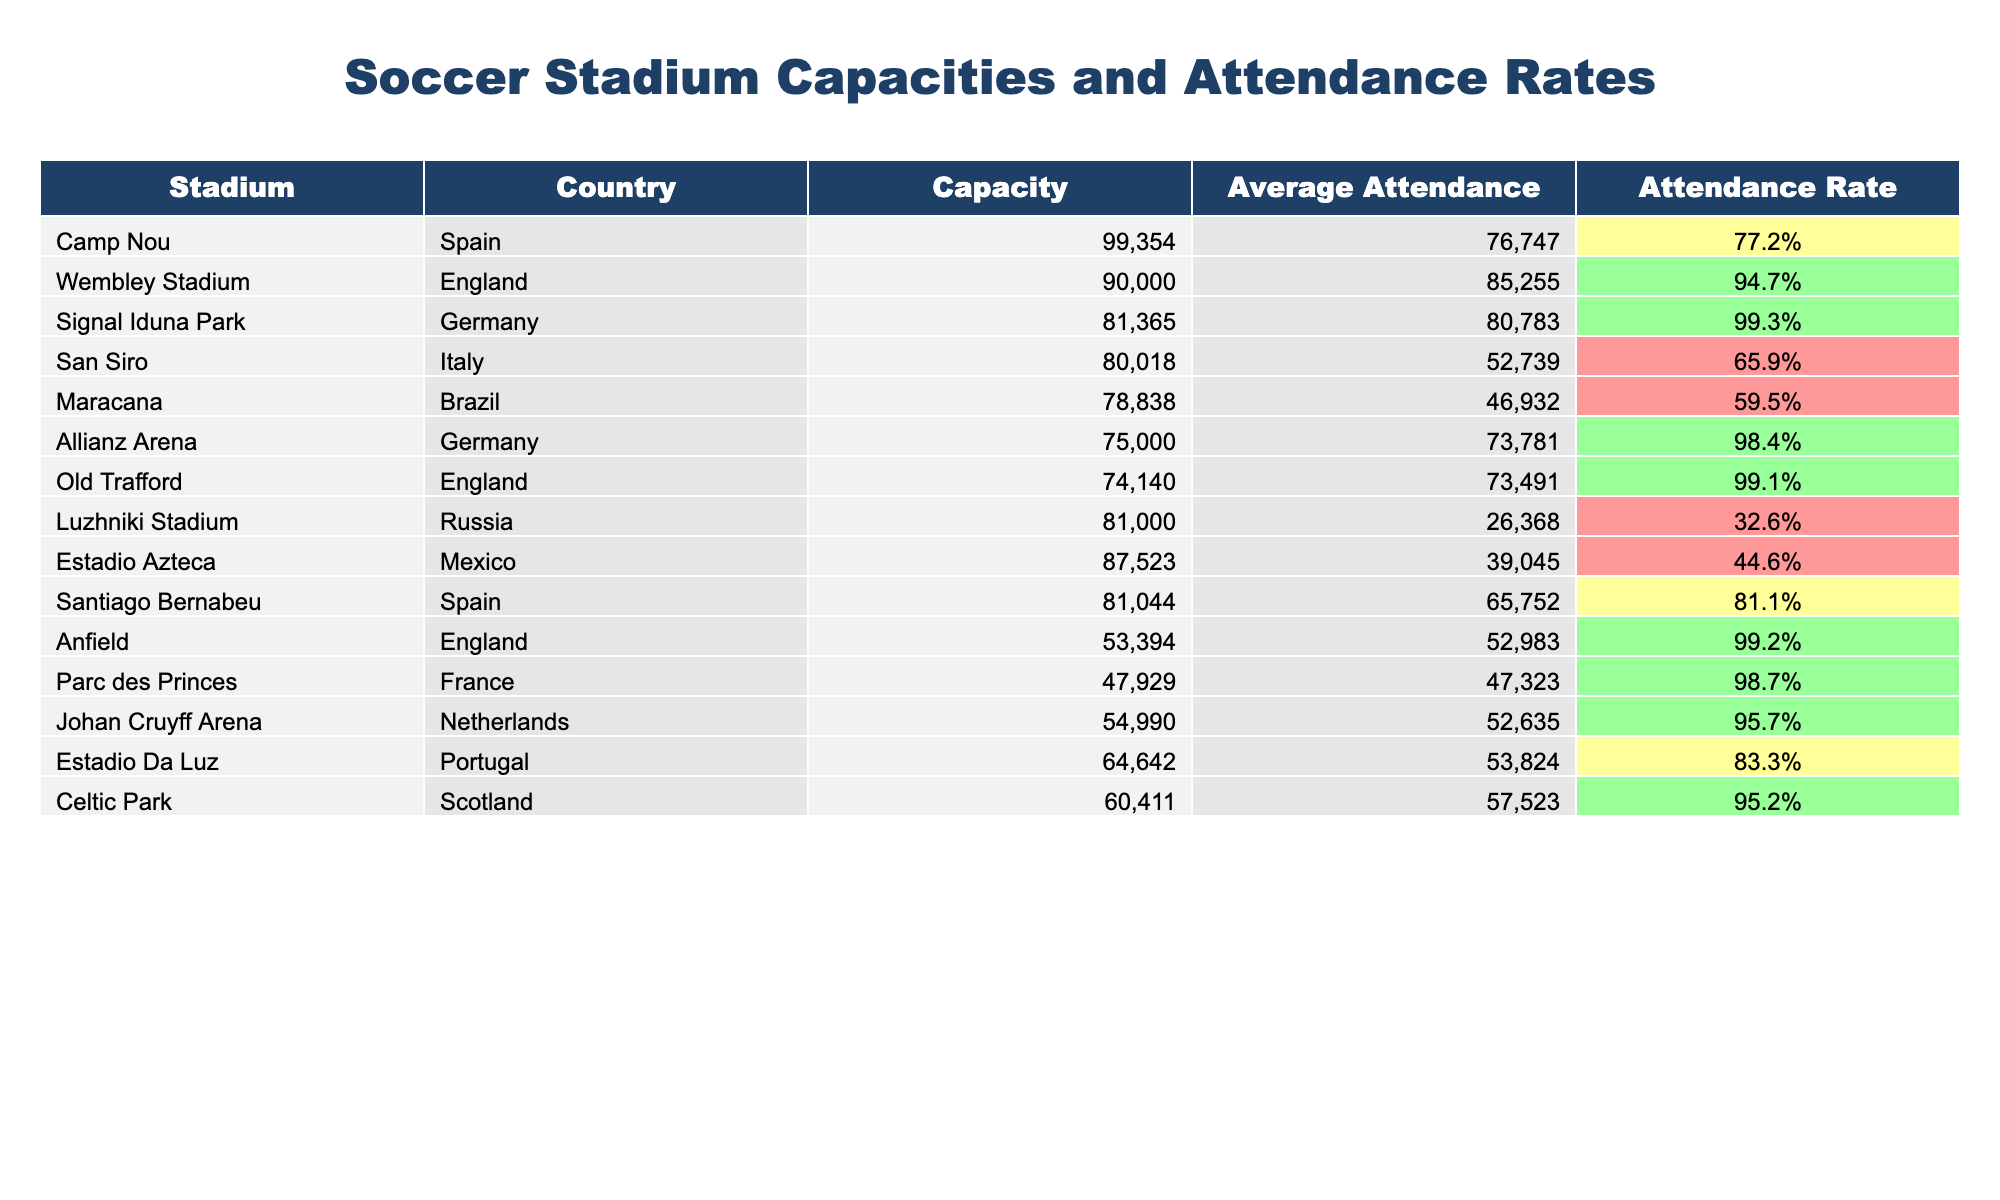What is the capacity of Camp Nou? The table lists Camp Nou under the 'Stadium' column, and directly across from it in the 'Capacity' column, the value is 99354.
Answer: 99354 Which stadium has the highest average attendance? By examining the 'Average Attendance' column, Signal Iduna Park has the highest value of 80783.
Answer: 80783 What is the attendance rate of Maracana? The attendance rate for Maracana can be found in the 'Attendance Rate' column, which shows 59.5%.
Answer: 59.5% Which stadium has the lowest attendance rate? By comparing the values in the 'Attendance Rate' column, Luzhniki Stadium has the lowest rate at 32.6%.
Answer: 32.6% Calculate the difference in average attendance between Wembley Stadium and San Siro. The average attendance of Wembley Stadium is 85255 and for San Siro, it is 52739. The difference is calculated as 85255 - 52739 = 32516.
Answer: 32516 How many stadiums have an attendance rate above 90%? By checking the 'Attendance Rate' column, there are five stadiums with rates above 90%: Wembley Stadium, Signal Iduna Park, Allianz Arena, Old Trafford, and Anfield.
Answer: 5 Is the average attendance of Estadio Azteca greater than that of San Siro? The average attendance for Estadio Azteca is 39045, and for San Siro, it is 52739. Since 39045 is less than 52739, the statement is false.
Answer: No Which stadium, among those in England, has the highest capacity? Reviewing the 'Capacity' column for stadiums listed under England, Wembley Stadium has the highest capacity at 90000.
Answer: 90000 If we consider only the three stadiums with the highest capacities, what is their average attendance? The three highest capacities belong to Camp Nou (76747), Wembley Stadium (85255), and Signal Iduna Park (80783). The average attendance is calculated as (76747 + 85255 + 80783) / 3 = 80962.33.
Answer: 80962.33 Are there more stadiums in Europe or South America according to this table? Examining the countries, there are 9 stadiums from Europe and 1 from South America (Maracana). Thus, there are more stadiums in Europe.
Answer: Yes 